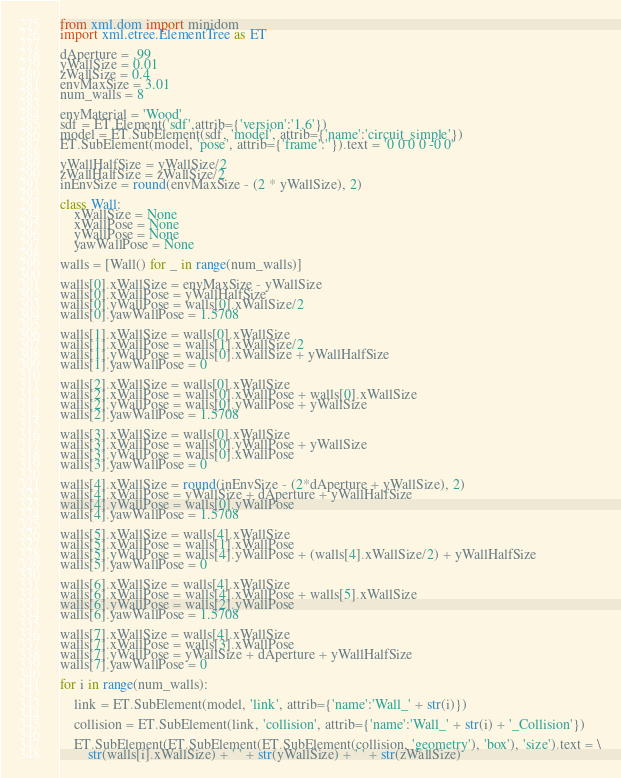<code> <loc_0><loc_0><loc_500><loc_500><_Python_>from xml.dom import minidom
import xml.etree.ElementTree as ET

dAperture = .99
yWallSize = 0.01
zWallSize = 0.4
envMaxSize = 3.01
num_walls = 8

envMaterial = 'Wood'
sdf = ET.Element('sdf',attrib={'version':'1.6'})
model = ET.SubElement(sdf, 'model', attrib={'name':'circuit_simple'})
ET.SubElement(model, 'pose', attrib={'frame':''}).text = '0 0 0 0 -0 0'

yWallHalfSize = yWallSize/2
zWallHalfSize = zWallSize/2
inEnvSize = round(envMaxSize - (2 * yWallSize), 2)

class Wall:
    xWallSize = None
    xWallPose = None
    yWallPose = None
    yawWallPose = None

walls = [Wall() for _ in range(num_walls)]

walls[0].xWallSize = envMaxSize - yWallSize
walls[0].xWallPose = yWallHalfSize
walls[0].yWallPose = walls[0].xWallSize/2
walls[0].yawWallPose = 1.5708

walls[1].xWallSize = walls[0].xWallSize
walls[1].xWallPose = walls[1].xWallSize/2
walls[1].yWallPose = walls[0].xWallSize + yWallHalfSize
walls[1].yawWallPose = 0

walls[2].xWallSize = walls[0].xWallSize
walls[2].xWallPose = walls[0].xWallPose + walls[0].xWallSize
walls[2].yWallPose = walls[0].yWallPose + yWallSize
walls[2].yawWallPose = 1.5708

walls[3].xWallSize = walls[0].xWallSize
walls[3].xWallPose = walls[0].yWallPose + yWallSize
walls[3].yWallPose = walls[0].xWallPose
walls[3].yawWallPose = 0

walls[4].xWallSize = round(inEnvSize - (2*dAperture + yWallSize), 2)
walls[4].xWallPose = yWallSize + dAperture + yWallHalfSize
walls[4].yWallPose = walls[0].yWallPose
walls[4].yawWallPose = 1.5708

walls[5].xWallSize = walls[4].xWallSize
walls[5].xWallPose = walls[1].xWallPose
walls[5].yWallPose = walls[4].yWallPose + (walls[4].xWallSize/2) + yWallHalfSize
walls[5].yawWallPose = 0

walls[6].xWallSize = walls[4].xWallSize
walls[6].xWallPose = walls[4].xWallPose + walls[5].xWallSize
walls[6].yWallPose = walls[2].yWallPose
walls[6].yawWallPose = 1.5708

walls[7].xWallSize = walls[4].xWallSize
walls[7].xWallPose = walls[3].xWallPose
walls[7].yWallPose = yWallSize + dAperture + yWallHalfSize
walls[7].yawWallPose = 0

for i in range(num_walls):

    link = ET.SubElement(model, 'link', attrib={'name':'Wall_' + str(i)})

    collision = ET.SubElement(link, 'collision', attrib={'name':'Wall_' + str(i) + '_Collision'})

    ET.SubElement(ET.SubElement(ET.SubElement(collision, 'geometry'), 'box'), 'size').text = \
        str(walls[i].xWallSize) + ' ' + str(yWallSize) + ' ' + str(zWallSize)
</code> 